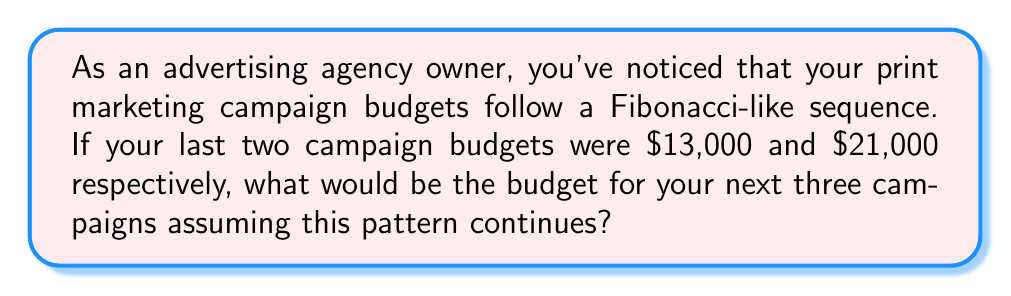Show me your answer to this math problem. To solve this problem, we need to understand and apply the Fibonacci sequence concept:

1. Recall that in a Fibonacci sequence, each number is the sum of the two preceding ones.

2. We're given the last two campaign budgets:
   $F_n = 13,000$
   $F_{n+1} = 21,000$

3. Let's calculate the next three terms:

   a) $F_{n+2} = F_n + F_{n+1} = 13,000 + 21,000 = 34,000$

   b) $F_{n+3} = F_{n+1} + F_{n+2} = 21,000 + 34,000 = 55,000$

   c) $F_{n+4} = F_{n+2} + F_{n+3} = 34,000 + 55,000 = 89,000$

4. Therefore, the budgets for the next three campaigns would be:
   $34,000, $55,000, and $89,000.

We can express this mathematically as:

$$F_{n+2} = F_n + F_{n+1}$$
$$F_{n+3} = F_{n+1} + F_{n+2}$$
$$F_{n+4} = F_{n+2} + F_{n+3}$$

Where $F_n$ represents the nth term in the sequence.
Answer: $34,000, $55,000, $89,000 